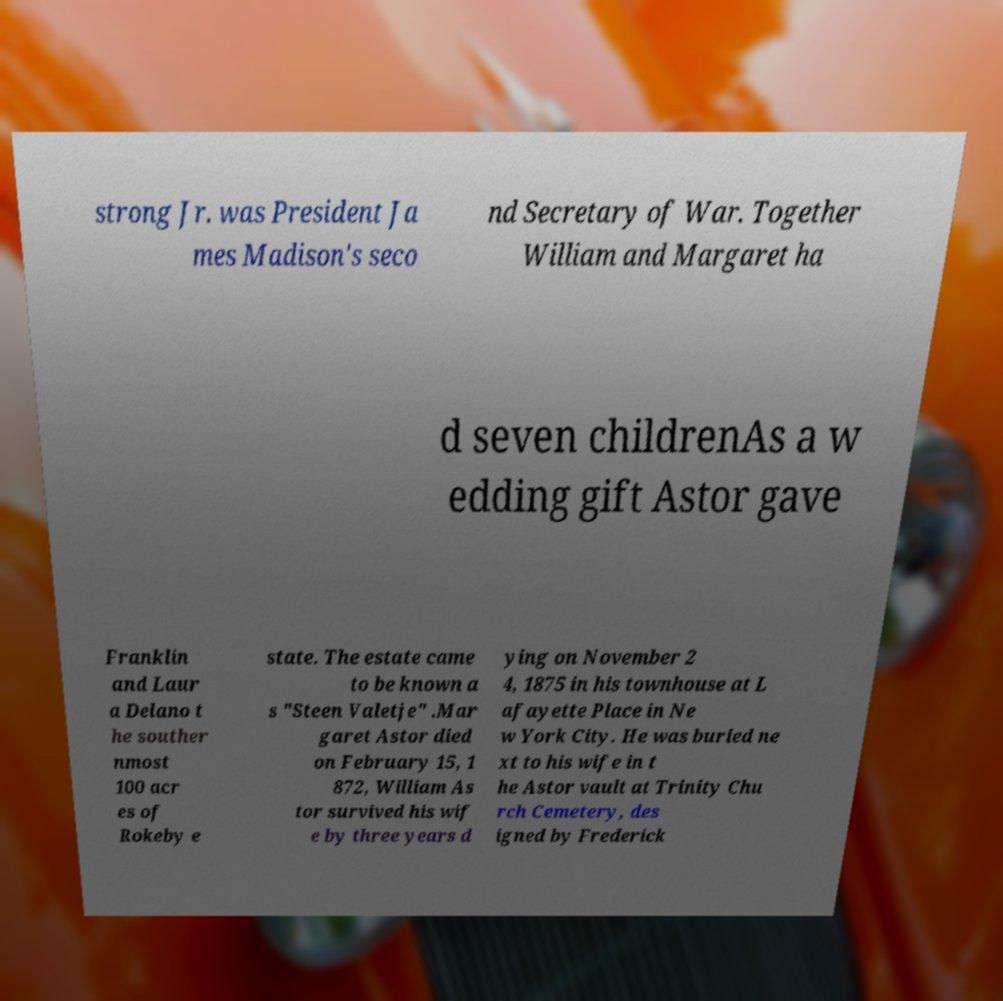Please read and relay the text visible in this image. What does it say? strong Jr. was President Ja mes Madison's seco nd Secretary of War. Together William and Margaret ha d seven childrenAs a w edding gift Astor gave Franklin and Laur a Delano t he souther nmost 100 acr es of Rokeby e state. The estate came to be known a s "Steen Valetje" .Mar garet Astor died on February 15, 1 872, William As tor survived his wif e by three years d ying on November 2 4, 1875 in his townhouse at L afayette Place in Ne w York City. He was buried ne xt to his wife in t he Astor vault at Trinity Chu rch Cemetery, des igned by Frederick 